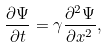Convert formula to latex. <formula><loc_0><loc_0><loc_500><loc_500>\frac { \partial \Psi } { \partial t } = \gamma \frac { \partial ^ { 2 } \Psi } { \partial x ^ { 2 } } ,</formula> 